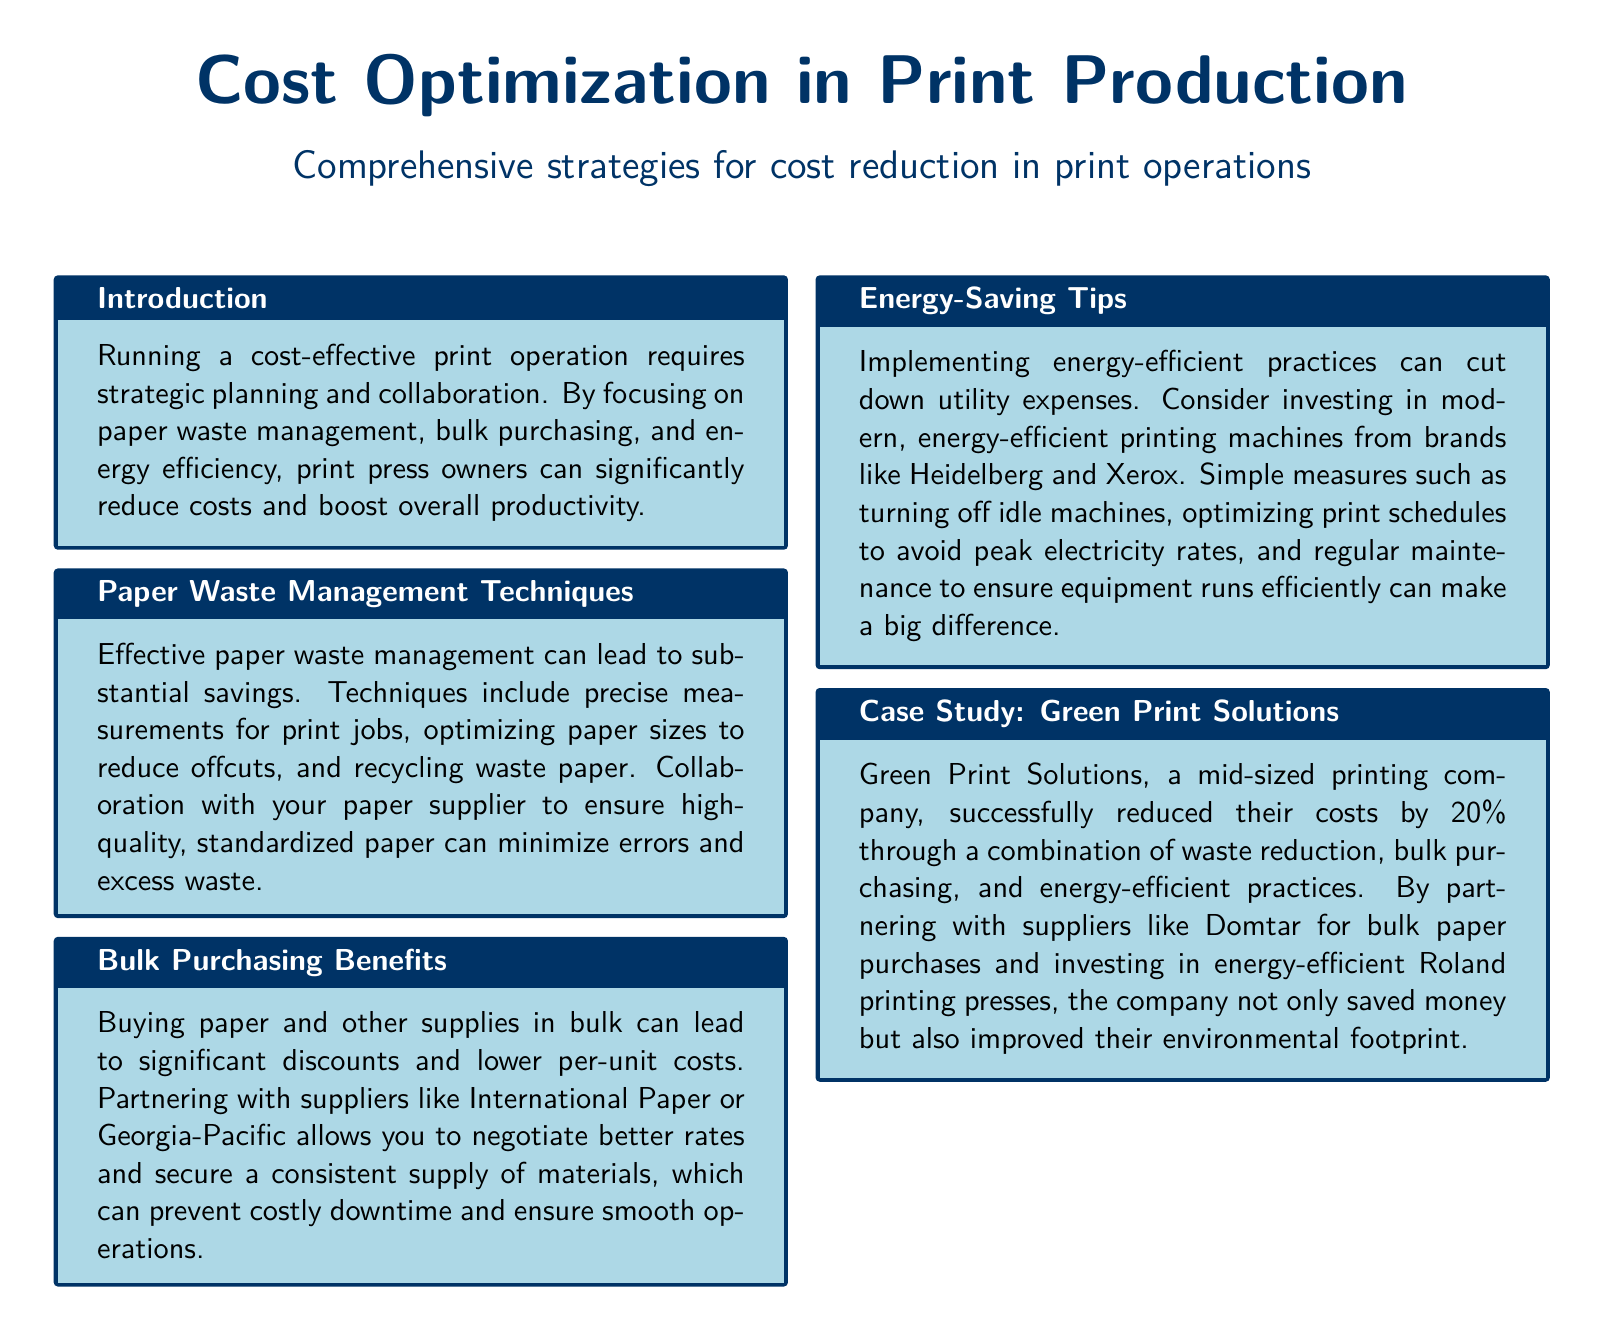what is the main topic of the document? The main topic is stated in the title at the beginning of the document, which is about cost optimization in print production.
Answer: Cost Optimization in Print Production what is one of the paper waste management techniques mentioned? The specific techniques are outlined in the section about paper waste management.
Answer: Recycling waste paper who is a recommended bulk purchasing supplier? The document lists several suppliers; one is highlighted for bulk purchasing benefits.
Answer: International Paper what percentage did Green Print Solutions reduce their costs by? The case study section provides this specific information about cost reduction.
Answer: 20% what is one energy-saving tip provided in the document? Energy-saving practices are discussed, and a specific tip is included in that section.
Answer: Turn off idle machines what is the purpose of the introduction section? The introduction outlines the overall goal of the strategies discussed in the document.
Answer: Strategic planning and collaboration name one brand of energy-efficient printing machines suggested. The energy-saving tips include recommendations for specific machine brands.
Answer: Heidelberg which section discusses the savings from bulk purchasing? The specific section dedicated to this topic outlines the benefits of bulk purchasing.
Answer: Bulk Purchasing Benefits 